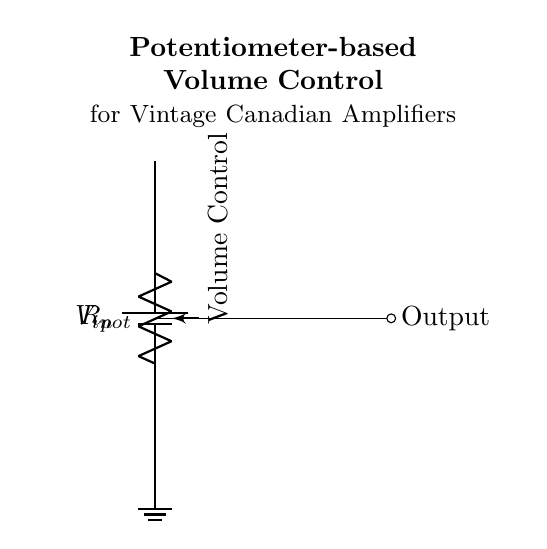What is the type of component used for volume control? The circuit uses a potentiometer as the primary component for volume control, which is indicated clearly in the diagram with the label "Volume Control."
Answer: Potentiometer What is the function of the wiper in this circuit? The wiper in the potentiometer connects to the output, allowing the user to adjust the resistance and thereby the voltage output, which directly controls the volume.
Answer: Voltage adjustment What connects the potentiometer's wiper to the output? The wiper is connected to the output via a short connection, as shown by the line directly leading from the wiper to the output node.
Answer: Short connection What is the voltage source in this circuit? The voltage source is labeled as \( V_{in} \) and is represented by the battery symbol at the top of the circuit diagram.
Answer: V in Explain how changing the potentiometer affects the output voltage. Adjusting the potentiometer changes the resistance across the wiper, which alters the division of input voltage between the two terminals of the potentiometer. This resultant voltage at the wiper becomes the output voltage, influencing the audio level.
Answer: Changes output voltage What does the ground symbol represent in this circuit? The ground symbol represents a reference point in the circuit, which is essential for completing the circuit and establishing a zero-voltage level for the circuit's operation.
Answer: Reference point 